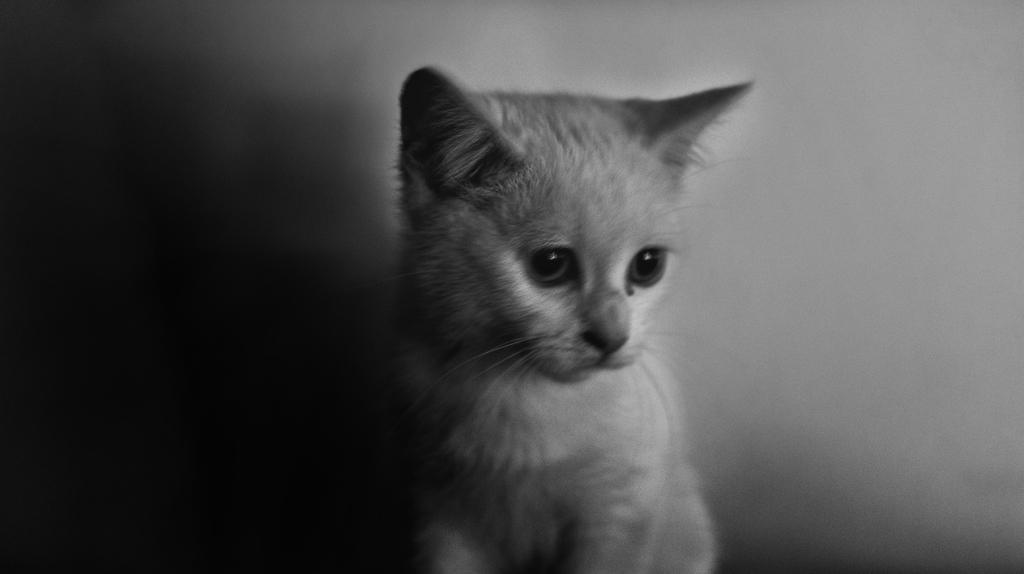What type of animal is present in the image? There is a cat in the image. Can you describe the view on the left side of the image? The view on the left side of the image is dark. What type of jar is visible on the right side of the image? There is no jar present in the image. Can you tell me how many actors are in the image? There are no actors present in the image. 